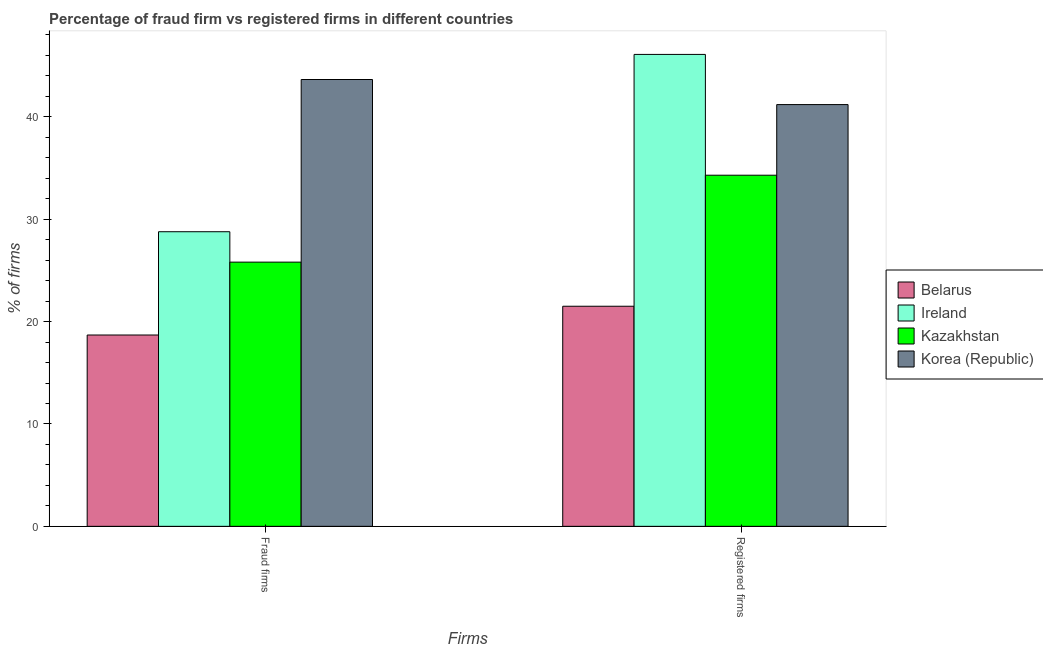Are the number of bars on each tick of the X-axis equal?
Offer a very short reply. Yes. How many bars are there on the 1st tick from the right?
Your answer should be very brief. 4. What is the label of the 2nd group of bars from the left?
Ensure brevity in your answer.  Registered firms. What is the percentage of fraud firms in Kazakhstan?
Offer a very short reply. 25.81. Across all countries, what is the maximum percentage of fraud firms?
Give a very brief answer. 43.65. Across all countries, what is the minimum percentage of fraud firms?
Your response must be concise. 18.69. In which country was the percentage of registered firms maximum?
Give a very brief answer. Ireland. In which country was the percentage of registered firms minimum?
Make the answer very short. Belarus. What is the total percentage of registered firms in the graph?
Offer a terse response. 143.1. What is the difference between the percentage of fraud firms in Belarus and that in Korea (Republic)?
Provide a short and direct response. -24.96. What is the difference between the percentage of fraud firms in Korea (Republic) and the percentage of registered firms in Kazakhstan?
Provide a short and direct response. 9.35. What is the average percentage of fraud firms per country?
Offer a terse response. 29.23. What is the difference between the percentage of registered firms and percentage of fraud firms in Kazakhstan?
Give a very brief answer. 8.49. In how many countries, is the percentage of registered firms greater than 32 %?
Ensure brevity in your answer.  3. What is the ratio of the percentage of fraud firms in Kazakhstan to that in Ireland?
Give a very brief answer. 0.9. Is the percentage of registered firms in Belarus less than that in Ireland?
Your answer should be very brief. Yes. What does the 1st bar from the left in Registered firms represents?
Provide a short and direct response. Belarus. Are all the bars in the graph horizontal?
Your answer should be compact. No. How many countries are there in the graph?
Your answer should be compact. 4. Are the values on the major ticks of Y-axis written in scientific E-notation?
Your answer should be very brief. No. Does the graph contain any zero values?
Your answer should be compact. No. Does the graph contain grids?
Your response must be concise. No. How many legend labels are there?
Make the answer very short. 4. How are the legend labels stacked?
Your answer should be very brief. Vertical. What is the title of the graph?
Your response must be concise. Percentage of fraud firm vs registered firms in different countries. Does "Slovak Republic" appear as one of the legend labels in the graph?
Provide a short and direct response. No. What is the label or title of the X-axis?
Offer a terse response. Firms. What is the label or title of the Y-axis?
Keep it short and to the point. % of firms. What is the % of firms in Belarus in Fraud firms?
Ensure brevity in your answer.  18.69. What is the % of firms of Ireland in Fraud firms?
Ensure brevity in your answer.  28.78. What is the % of firms of Kazakhstan in Fraud firms?
Offer a very short reply. 25.81. What is the % of firms in Korea (Republic) in Fraud firms?
Your answer should be very brief. 43.65. What is the % of firms of Belarus in Registered firms?
Make the answer very short. 21.5. What is the % of firms in Ireland in Registered firms?
Provide a succinct answer. 46.1. What is the % of firms of Kazakhstan in Registered firms?
Your answer should be compact. 34.3. What is the % of firms of Korea (Republic) in Registered firms?
Give a very brief answer. 41.2. Across all Firms, what is the maximum % of firms in Ireland?
Make the answer very short. 46.1. Across all Firms, what is the maximum % of firms of Kazakhstan?
Your answer should be compact. 34.3. Across all Firms, what is the maximum % of firms in Korea (Republic)?
Your response must be concise. 43.65. Across all Firms, what is the minimum % of firms of Belarus?
Provide a short and direct response. 18.69. Across all Firms, what is the minimum % of firms of Ireland?
Keep it short and to the point. 28.78. Across all Firms, what is the minimum % of firms in Kazakhstan?
Give a very brief answer. 25.81. Across all Firms, what is the minimum % of firms of Korea (Republic)?
Your response must be concise. 41.2. What is the total % of firms of Belarus in the graph?
Provide a succinct answer. 40.19. What is the total % of firms of Ireland in the graph?
Your answer should be compact. 74.88. What is the total % of firms in Kazakhstan in the graph?
Your answer should be compact. 60.11. What is the total % of firms in Korea (Republic) in the graph?
Your answer should be compact. 84.85. What is the difference between the % of firms in Belarus in Fraud firms and that in Registered firms?
Your response must be concise. -2.81. What is the difference between the % of firms of Ireland in Fraud firms and that in Registered firms?
Your answer should be compact. -17.32. What is the difference between the % of firms in Kazakhstan in Fraud firms and that in Registered firms?
Offer a very short reply. -8.49. What is the difference between the % of firms of Korea (Republic) in Fraud firms and that in Registered firms?
Provide a succinct answer. 2.45. What is the difference between the % of firms of Belarus in Fraud firms and the % of firms of Ireland in Registered firms?
Your answer should be very brief. -27.41. What is the difference between the % of firms in Belarus in Fraud firms and the % of firms in Kazakhstan in Registered firms?
Ensure brevity in your answer.  -15.61. What is the difference between the % of firms of Belarus in Fraud firms and the % of firms of Korea (Republic) in Registered firms?
Your response must be concise. -22.51. What is the difference between the % of firms of Ireland in Fraud firms and the % of firms of Kazakhstan in Registered firms?
Offer a very short reply. -5.52. What is the difference between the % of firms of Ireland in Fraud firms and the % of firms of Korea (Republic) in Registered firms?
Your answer should be compact. -12.42. What is the difference between the % of firms of Kazakhstan in Fraud firms and the % of firms of Korea (Republic) in Registered firms?
Provide a short and direct response. -15.39. What is the average % of firms of Belarus per Firms?
Your answer should be compact. 20.09. What is the average % of firms in Ireland per Firms?
Give a very brief answer. 37.44. What is the average % of firms of Kazakhstan per Firms?
Provide a succinct answer. 30.05. What is the average % of firms in Korea (Republic) per Firms?
Keep it short and to the point. 42.42. What is the difference between the % of firms in Belarus and % of firms in Ireland in Fraud firms?
Make the answer very short. -10.09. What is the difference between the % of firms of Belarus and % of firms of Kazakhstan in Fraud firms?
Provide a short and direct response. -7.12. What is the difference between the % of firms in Belarus and % of firms in Korea (Republic) in Fraud firms?
Ensure brevity in your answer.  -24.96. What is the difference between the % of firms in Ireland and % of firms in Kazakhstan in Fraud firms?
Make the answer very short. 2.97. What is the difference between the % of firms of Ireland and % of firms of Korea (Republic) in Fraud firms?
Offer a very short reply. -14.87. What is the difference between the % of firms of Kazakhstan and % of firms of Korea (Republic) in Fraud firms?
Ensure brevity in your answer.  -17.84. What is the difference between the % of firms in Belarus and % of firms in Ireland in Registered firms?
Offer a terse response. -24.6. What is the difference between the % of firms of Belarus and % of firms of Kazakhstan in Registered firms?
Make the answer very short. -12.8. What is the difference between the % of firms in Belarus and % of firms in Korea (Republic) in Registered firms?
Your answer should be very brief. -19.7. What is the difference between the % of firms in Ireland and % of firms in Kazakhstan in Registered firms?
Give a very brief answer. 11.8. What is the ratio of the % of firms in Belarus in Fraud firms to that in Registered firms?
Give a very brief answer. 0.87. What is the ratio of the % of firms in Ireland in Fraud firms to that in Registered firms?
Give a very brief answer. 0.62. What is the ratio of the % of firms of Kazakhstan in Fraud firms to that in Registered firms?
Offer a very short reply. 0.75. What is the ratio of the % of firms of Korea (Republic) in Fraud firms to that in Registered firms?
Give a very brief answer. 1.06. What is the difference between the highest and the second highest % of firms in Belarus?
Provide a succinct answer. 2.81. What is the difference between the highest and the second highest % of firms in Ireland?
Keep it short and to the point. 17.32. What is the difference between the highest and the second highest % of firms of Kazakhstan?
Give a very brief answer. 8.49. What is the difference between the highest and the second highest % of firms of Korea (Republic)?
Give a very brief answer. 2.45. What is the difference between the highest and the lowest % of firms in Belarus?
Offer a very short reply. 2.81. What is the difference between the highest and the lowest % of firms in Ireland?
Your response must be concise. 17.32. What is the difference between the highest and the lowest % of firms in Kazakhstan?
Make the answer very short. 8.49. What is the difference between the highest and the lowest % of firms of Korea (Republic)?
Your answer should be compact. 2.45. 